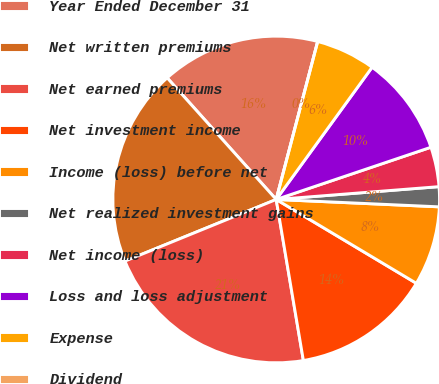<chart> <loc_0><loc_0><loc_500><loc_500><pie_chart><fcel>Year Ended December 31<fcel>Net written premiums<fcel>Net earned premiums<fcel>Net investment income<fcel>Income (loss) before net<fcel>Net realized investment gains<fcel>Net income (loss)<fcel>Loss and loss adjustment<fcel>Expense<fcel>Dividend<nl><fcel>15.72%<fcel>19.53%<fcel>21.5%<fcel>13.76%<fcel>7.86%<fcel>1.97%<fcel>3.93%<fcel>9.83%<fcel>5.9%<fcel>0.0%<nl></chart> 